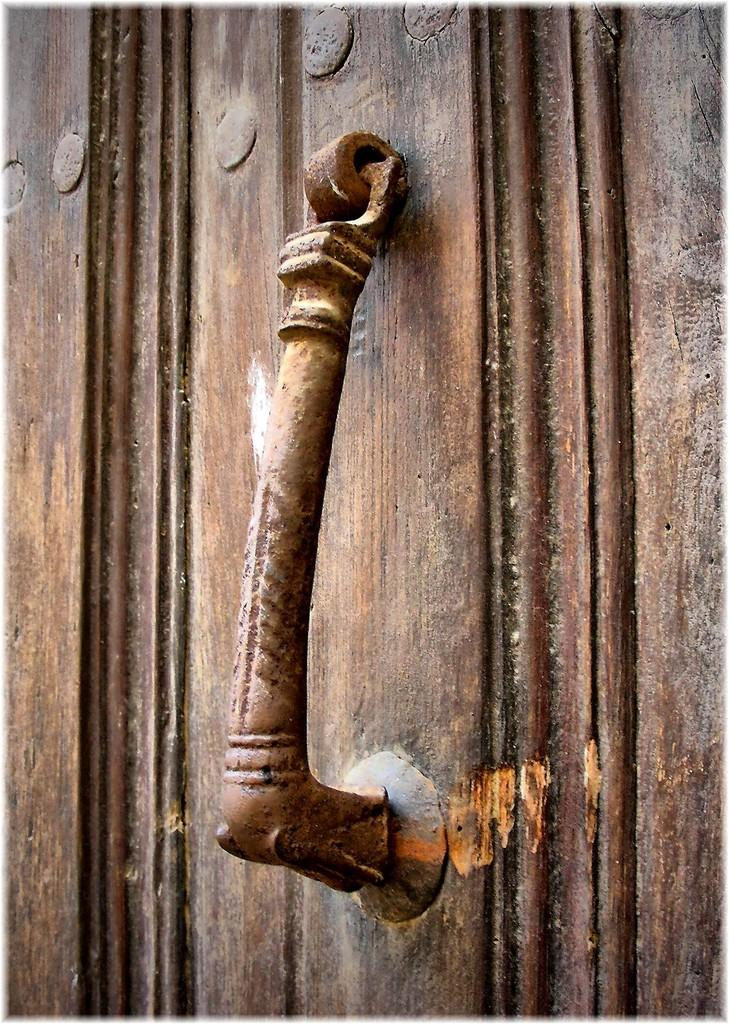What is located in the foreground of the image? There is a handle to a door in the foreground of the image. How many kittens are sitting on the sheet in the image? There are no kittens or sheets present in the image; it only features a handle to a door. 